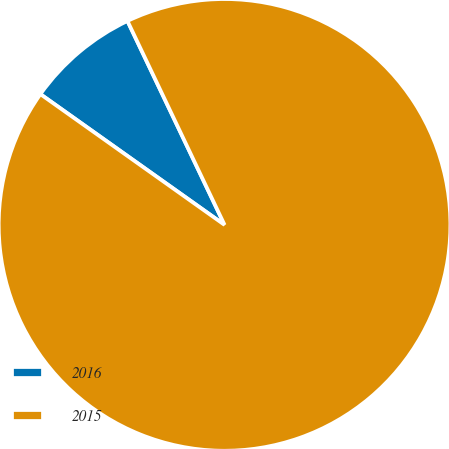Convert chart. <chart><loc_0><loc_0><loc_500><loc_500><pie_chart><fcel>2016<fcel>2015<nl><fcel>8.1%<fcel>91.9%<nl></chart> 